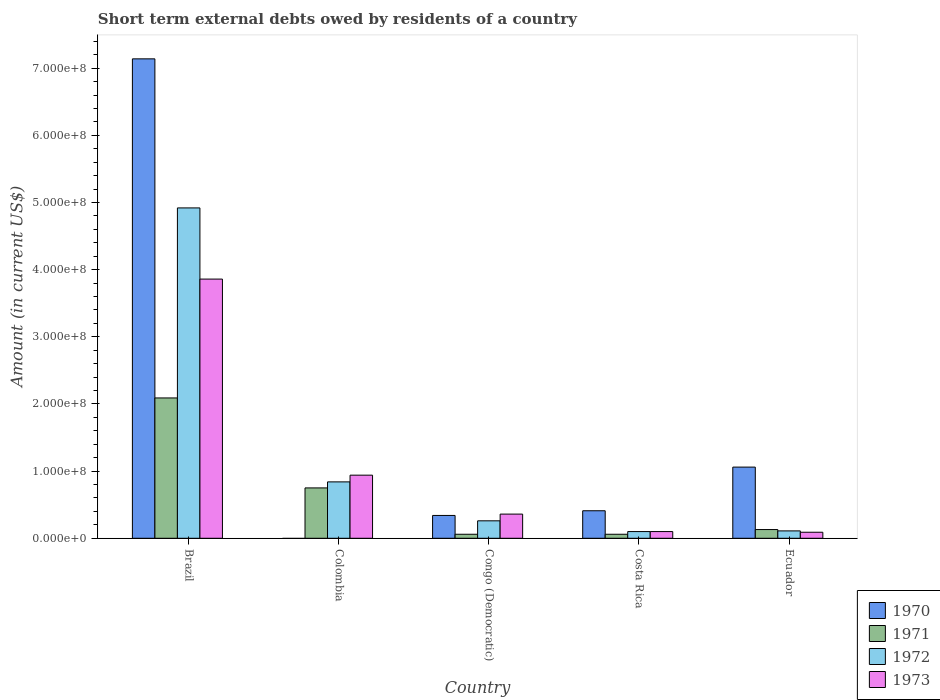How many groups of bars are there?
Offer a terse response. 5. Are the number of bars per tick equal to the number of legend labels?
Your answer should be compact. No. What is the label of the 5th group of bars from the left?
Provide a short and direct response. Ecuador. What is the amount of short-term external debts owed by residents in 1971 in Ecuador?
Make the answer very short. 1.30e+07. Across all countries, what is the maximum amount of short-term external debts owed by residents in 1972?
Ensure brevity in your answer.  4.92e+08. Across all countries, what is the minimum amount of short-term external debts owed by residents in 1972?
Ensure brevity in your answer.  1.00e+07. In which country was the amount of short-term external debts owed by residents in 1970 maximum?
Ensure brevity in your answer.  Brazil. What is the total amount of short-term external debts owed by residents in 1971 in the graph?
Your answer should be compact. 3.09e+08. What is the difference between the amount of short-term external debts owed by residents in 1973 in Colombia and that in Congo (Democratic)?
Keep it short and to the point. 5.80e+07. What is the difference between the amount of short-term external debts owed by residents in 1972 in Colombia and the amount of short-term external debts owed by residents in 1973 in Brazil?
Keep it short and to the point. -3.02e+08. What is the average amount of short-term external debts owed by residents in 1970 per country?
Ensure brevity in your answer.  1.79e+08. What is the difference between the amount of short-term external debts owed by residents of/in 1971 and amount of short-term external debts owed by residents of/in 1973 in Colombia?
Your response must be concise. -1.90e+07. In how many countries, is the amount of short-term external debts owed by residents in 1973 greater than 380000000 US$?
Your answer should be compact. 1. What is the ratio of the amount of short-term external debts owed by residents in 1972 in Colombia to that in Congo (Democratic)?
Your answer should be very brief. 3.23. Is the amount of short-term external debts owed by residents in 1971 in Brazil less than that in Costa Rica?
Give a very brief answer. No. What is the difference between the highest and the second highest amount of short-term external debts owed by residents in 1970?
Keep it short and to the point. 6.73e+08. What is the difference between the highest and the lowest amount of short-term external debts owed by residents in 1970?
Offer a terse response. 7.14e+08. Is it the case that in every country, the sum of the amount of short-term external debts owed by residents in 1970 and amount of short-term external debts owed by residents in 1973 is greater than the amount of short-term external debts owed by residents in 1972?
Offer a very short reply. Yes. Are all the bars in the graph horizontal?
Your answer should be very brief. No. How many countries are there in the graph?
Offer a very short reply. 5. Are the values on the major ticks of Y-axis written in scientific E-notation?
Provide a short and direct response. Yes. Does the graph contain any zero values?
Give a very brief answer. Yes. Where does the legend appear in the graph?
Provide a succinct answer. Bottom right. What is the title of the graph?
Offer a very short reply. Short term external debts owed by residents of a country. Does "1983" appear as one of the legend labels in the graph?
Keep it short and to the point. No. What is the label or title of the Y-axis?
Your answer should be compact. Amount (in current US$). What is the Amount (in current US$) in 1970 in Brazil?
Your answer should be compact. 7.14e+08. What is the Amount (in current US$) of 1971 in Brazil?
Your answer should be very brief. 2.09e+08. What is the Amount (in current US$) in 1972 in Brazil?
Offer a terse response. 4.92e+08. What is the Amount (in current US$) of 1973 in Brazil?
Offer a terse response. 3.86e+08. What is the Amount (in current US$) in 1971 in Colombia?
Offer a terse response. 7.50e+07. What is the Amount (in current US$) of 1972 in Colombia?
Provide a succinct answer. 8.40e+07. What is the Amount (in current US$) of 1973 in Colombia?
Your answer should be compact. 9.40e+07. What is the Amount (in current US$) of 1970 in Congo (Democratic)?
Your answer should be very brief. 3.40e+07. What is the Amount (in current US$) in 1972 in Congo (Democratic)?
Offer a terse response. 2.60e+07. What is the Amount (in current US$) of 1973 in Congo (Democratic)?
Provide a short and direct response. 3.60e+07. What is the Amount (in current US$) of 1970 in Costa Rica?
Provide a short and direct response. 4.10e+07. What is the Amount (in current US$) of 1971 in Costa Rica?
Make the answer very short. 6.00e+06. What is the Amount (in current US$) in 1972 in Costa Rica?
Offer a terse response. 1.00e+07. What is the Amount (in current US$) of 1970 in Ecuador?
Ensure brevity in your answer.  1.06e+08. What is the Amount (in current US$) in 1971 in Ecuador?
Your answer should be very brief. 1.30e+07. What is the Amount (in current US$) in 1972 in Ecuador?
Your answer should be compact. 1.10e+07. What is the Amount (in current US$) of 1973 in Ecuador?
Offer a very short reply. 9.00e+06. Across all countries, what is the maximum Amount (in current US$) in 1970?
Offer a terse response. 7.14e+08. Across all countries, what is the maximum Amount (in current US$) in 1971?
Make the answer very short. 2.09e+08. Across all countries, what is the maximum Amount (in current US$) of 1972?
Keep it short and to the point. 4.92e+08. Across all countries, what is the maximum Amount (in current US$) in 1973?
Your response must be concise. 3.86e+08. Across all countries, what is the minimum Amount (in current US$) of 1973?
Keep it short and to the point. 9.00e+06. What is the total Amount (in current US$) in 1970 in the graph?
Offer a very short reply. 8.95e+08. What is the total Amount (in current US$) in 1971 in the graph?
Give a very brief answer. 3.09e+08. What is the total Amount (in current US$) in 1972 in the graph?
Give a very brief answer. 6.23e+08. What is the total Amount (in current US$) in 1973 in the graph?
Offer a very short reply. 5.35e+08. What is the difference between the Amount (in current US$) of 1971 in Brazil and that in Colombia?
Offer a terse response. 1.34e+08. What is the difference between the Amount (in current US$) of 1972 in Brazil and that in Colombia?
Your answer should be compact. 4.08e+08. What is the difference between the Amount (in current US$) in 1973 in Brazil and that in Colombia?
Ensure brevity in your answer.  2.92e+08. What is the difference between the Amount (in current US$) in 1970 in Brazil and that in Congo (Democratic)?
Make the answer very short. 6.80e+08. What is the difference between the Amount (in current US$) in 1971 in Brazil and that in Congo (Democratic)?
Provide a succinct answer. 2.03e+08. What is the difference between the Amount (in current US$) in 1972 in Brazil and that in Congo (Democratic)?
Keep it short and to the point. 4.66e+08. What is the difference between the Amount (in current US$) in 1973 in Brazil and that in Congo (Democratic)?
Keep it short and to the point. 3.50e+08. What is the difference between the Amount (in current US$) in 1970 in Brazil and that in Costa Rica?
Your answer should be very brief. 6.73e+08. What is the difference between the Amount (in current US$) of 1971 in Brazil and that in Costa Rica?
Ensure brevity in your answer.  2.03e+08. What is the difference between the Amount (in current US$) in 1972 in Brazil and that in Costa Rica?
Ensure brevity in your answer.  4.82e+08. What is the difference between the Amount (in current US$) of 1973 in Brazil and that in Costa Rica?
Provide a succinct answer. 3.76e+08. What is the difference between the Amount (in current US$) of 1970 in Brazil and that in Ecuador?
Make the answer very short. 6.08e+08. What is the difference between the Amount (in current US$) in 1971 in Brazil and that in Ecuador?
Give a very brief answer. 1.96e+08. What is the difference between the Amount (in current US$) in 1972 in Brazil and that in Ecuador?
Give a very brief answer. 4.81e+08. What is the difference between the Amount (in current US$) of 1973 in Brazil and that in Ecuador?
Your answer should be compact. 3.77e+08. What is the difference between the Amount (in current US$) in 1971 in Colombia and that in Congo (Democratic)?
Keep it short and to the point. 6.90e+07. What is the difference between the Amount (in current US$) in 1972 in Colombia and that in Congo (Democratic)?
Your answer should be very brief. 5.80e+07. What is the difference between the Amount (in current US$) in 1973 in Colombia and that in Congo (Democratic)?
Offer a very short reply. 5.80e+07. What is the difference between the Amount (in current US$) of 1971 in Colombia and that in Costa Rica?
Make the answer very short. 6.90e+07. What is the difference between the Amount (in current US$) in 1972 in Colombia and that in Costa Rica?
Your answer should be very brief. 7.40e+07. What is the difference between the Amount (in current US$) in 1973 in Colombia and that in Costa Rica?
Provide a short and direct response. 8.40e+07. What is the difference between the Amount (in current US$) of 1971 in Colombia and that in Ecuador?
Offer a very short reply. 6.20e+07. What is the difference between the Amount (in current US$) of 1972 in Colombia and that in Ecuador?
Provide a succinct answer. 7.30e+07. What is the difference between the Amount (in current US$) in 1973 in Colombia and that in Ecuador?
Give a very brief answer. 8.50e+07. What is the difference between the Amount (in current US$) of 1970 in Congo (Democratic) and that in Costa Rica?
Offer a very short reply. -7.00e+06. What is the difference between the Amount (in current US$) in 1972 in Congo (Democratic) and that in Costa Rica?
Give a very brief answer. 1.60e+07. What is the difference between the Amount (in current US$) of 1973 in Congo (Democratic) and that in Costa Rica?
Provide a short and direct response. 2.60e+07. What is the difference between the Amount (in current US$) in 1970 in Congo (Democratic) and that in Ecuador?
Your response must be concise. -7.20e+07. What is the difference between the Amount (in current US$) of 1971 in Congo (Democratic) and that in Ecuador?
Offer a very short reply. -7.00e+06. What is the difference between the Amount (in current US$) in 1972 in Congo (Democratic) and that in Ecuador?
Offer a terse response. 1.50e+07. What is the difference between the Amount (in current US$) of 1973 in Congo (Democratic) and that in Ecuador?
Offer a terse response. 2.70e+07. What is the difference between the Amount (in current US$) in 1970 in Costa Rica and that in Ecuador?
Ensure brevity in your answer.  -6.50e+07. What is the difference between the Amount (in current US$) in 1971 in Costa Rica and that in Ecuador?
Make the answer very short. -7.00e+06. What is the difference between the Amount (in current US$) of 1973 in Costa Rica and that in Ecuador?
Ensure brevity in your answer.  1.00e+06. What is the difference between the Amount (in current US$) of 1970 in Brazil and the Amount (in current US$) of 1971 in Colombia?
Offer a very short reply. 6.39e+08. What is the difference between the Amount (in current US$) of 1970 in Brazil and the Amount (in current US$) of 1972 in Colombia?
Your response must be concise. 6.30e+08. What is the difference between the Amount (in current US$) of 1970 in Brazil and the Amount (in current US$) of 1973 in Colombia?
Your answer should be compact. 6.20e+08. What is the difference between the Amount (in current US$) in 1971 in Brazil and the Amount (in current US$) in 1972 in Colombia?
Ensure brevity in your answer.  1.25e+08. What is the difference between the Amount (in current US$) of 1971 in Brazil and the Amount (in current US$) of 1973 in Colombia?
Give a very brief answer. 1.15e+08. What is the difference between the Amount (in current US$) of 1972 in Brazil and the Amount (in current US$) of 1973 in Colombia?
Offer a very short reply. 3.98e+08. What is the difference between the Amount (in current US$) of 1970 in Brazil and the Amount (in current US$) of 1971 in Congo (Democratic)?
Ensure brevity in your answer.  7.08e+08. What is the difference between the Amount (in current US$) in 1970 in Brazil and the Amount (in current US$) in 1972 in Congo (Democratic)?
Offer a very short reply. 6.88e+08. What is the difference between the Amount (in current US$) of 1970 in Brazil and the Amount (in current US$) of 1973 in Congo (Democratic)?
Offer a terse response. 6.78e+08. What is the difference between the Amount (in current US$) of 1971 in Brazil and the Amount (in current US$) of 1972 in Congo (Democratic)?
Your answer should be compact. 1.83e+08. What is the difference between the Amount (in current US$) in 1971 in Brazil and the Amount (in current US$) in 1973 in Congo (Democratic)?
Offer a very short reply. 1.73e+08. What is the difference between the Amount (in current US$) in 1972 in Brazil and the Amount (in current US$) in 1973 in Congo (Democratic)?
Offer a very short reply. 4.56e+08. What is the difference between the Amount (in current US$) in 1970 in Brazil and the Amount (in current US$) in 1971 in Costa Rica?
Your answer should be compact. 7.08e+08. What is the difference between the Amount (in current US$) of 1970 in Brazil and the Amount (in current US$) of 1972 in Costa Rica?
Give a very brief answer. 7.04e+08. What is the difference between the Amount (in current US$) in 1970 in Brazil and the Amount (in current US$) in 1973 in Costa Rica?
Ensure brevity in your answer.  7.04e+08. What is the difference between the Amount (in current US$) in 1971 in Brazil and the Amount (in current US$) in 1972 in Costa Rica?
Your answer should be compact. 1.99e+08. What is the difference between the Amount (in current US$) in 1971 in Brazil and the Amount (in current US$) in 1973 in Costa Rica?
Provide a succinct answer. 1.99e+08. What is the difference between the Amount (in current US$) in 1972 in Brazil and the Amount (in current US$) in 1973 in Costa Rica?
Offer a very short reply. 4.82e+08. What is the difference between the Amount (in current US$) of 1970 in Brazil and the Amount (in current US$) of 1971 in Ecuador?
Offer a terse response. 7.01e+08. What is the difference between the Amount (in current US$) of 1970 in Brazil and the Amount (in current US$) of 1972 in Ecuador?
Ensure brevity in your answer.  7.03e+08. What is the difference between the Amount (in current US$) of 1970 in Brazil and the Amount (in current US$) of 1973 in Ecuador?
Your answer should be compact. 7.05e+08. What is the difference between the Amount (in current US$) in 1971 in Brazil and the Amount (in current US$) in 1972 in Ecuador?
Make the answer very short. 1.98e+08. What is the difference between the Amount (in current US$) of 1972 in Brazil and the Amount (in current US$) of 1973 in Ecuador?
Offer a very short reply. 4.83e+08. What is the difference between the Amount (in current US$) in 1971 in Colombia and the Amount (in current US$) in 1972 in Congo (Democratic)?
Make the answer very short. 4.90e+07. What is the difference between the Amount (in current US$) of 1971 in Colombia and the Amount (in current US$) of 1973 in Congo (Democratic)?
Provide a succinct answer. 3.90e+07. What is the difference between the Amount (in current US$) in 1972 in Colombia and the Amount (in current US$) in 1973 in Congo (Democratic)?
Ensure brevity in your answer.  4.80e+07. What is the difference between the Amount (in current US$) of 1971 in Colombia and the Amount (in current US$) of 1972 in Costa Rica?
Make the answer very short. 6.50e+07. What is the difference between the Amount (in current US$) of 1971 in Colombia and the Amount (in current US$) of 1973 in Costa Rica?
Give a very brief answer. 6.50e+07. What is the difference between the Amount (in current US$) of 1972 in Colombia and the Amount (in current US$) of 1973 in Costa Rica?
Your answer should be very brief. 7.40e+07. What is the difference between the Amount (in current US$) in 1971 in Colombia and the Amount (in current US$) in 1972 in Ecuador?
Provide a short and direct response. 6.40e+07. What is the difference between the Amount (in current US$) in 1971 in Colombia and the Amount (in current US$) in 1973 in Ecuador?
Your answer should be very brief. 6.60e+07. What is the difference between the Amount (in current US$) of 1972 in Colombia and the Amount (in current US$) of 1973 in Ecuador?
Offer a very short reply. 7.50e+07. What is the difference between the Amount (in current US$) in 1970 in Congo (Democratic) and the Amount (in current US$) in 1971 in Costa Rica?
Give a very brief answer. 2.80e+07. What is the difference between the Amount (in current US$) of 1970 in Congo (Democratic) and the Amount (in current US$) of 1972 in Costa Rica?
Make the answer very short. 2.40e+07. What is the difference between the Amount (in current US$) of 1970 in Congo (Democratic) and the Amount (in current US$) of 1973 in Costa Rica?
Provide a succinct answer. 2.40e+07. What is the difference between the Amount (in current US$) of 1971 in Congo (Democratic) and the Amount (in current US$) of 1973 in Costa Rica?
Give a very brief answer. -4.00e+06. What is the difference between the Amount (in current US$) of 1972 in Congo (Democratic) and the Amount (in current US$) of 1973 in Costa Rica?
Ensure brevity in your answer.  1.60e+07. What is the difference between the Amount (in current US$) in 1970 in Congo (Democratic) and the Amount (in current US$) in 1971 in Ecuador?
Provide a succinct answer. 2.10e+07. What is the difference between the Amount (in current US$) of 1970 in Congo (Democratic) and the Amount (in current US$) of 1972 in Ecuador?
Your answer should be compact. 2.30e+07. What is the difference between the Amount (in current US$) of 1970 in Congo (Democratic) and the Amount (in current US$) of 1973 in Ecuador?
Give a very brief answer. 2.50e+07. What is the difference between the Amount (in current US$) of 1971 in Congo (Democratic) and the Amount (in current US$) of 1972 in Ecuador?
Keep it short and to the point. -5.00e+06. What is the difference between the Amount (in current US$) in 1972 in Congo (Democratic) and the Amount (in current US$) in 1973 in Ecuador?
Provide a succinct answer. 1.70e+07. What is the difference between the Amount (in current US$) in 1970 in Costa Rica and the Amount (in current US$) in 1971 in Ecuador?
Make the answer very short. 2.80e+07. What is the difference between the Amount (in current US$) of 1970 in Costa Rica and the Amount (in current US$) of 1972 in Ecuador?
Your answer should be very brief. 3.00e+07. What is the difference between the Amount (in current US$) of 1970 in Costa Rica and the Amount (in current US$) of 1973 in Ecuador?
Keep it short and to the point. 3.20e+07. What is the difference between the Amount (in current US$) in 1971 in Costa Rica and the Amount (in current US$) in 1972 in Ecuador?
Ensure brevity in your answer.  -5.00e+06. What is the difference between the Amount (in current US$) of 1971 in Costa Rica and the Amount (in current US$) of 1973 in Ecuador?
Offer a terse response. -3.00e+06. What is the average Amount (in current US$) in 1970 per country?
Provide a short and direct response. 1.79e+08. What is the average Amount (in current US$) of 1971 per country?
Provide a short and direct response. 6.18e+07. What is the average Amount (in current US$) of 1972 per country?
Offer a terse response. 1.25e+08. What is the average Amount (in current US$) in 1973 per country?
Keep it short and to the point. 1.07e+08. What is the difference between the Amount (in current US$) of 1970 and Amount (in current US$) of 1971 in Brazil?
Your answer should be compact. 5.05e+08. What is the difference between the Amount (in current US$) in 1970 and Amount (in current US$) in 1972 in Brazil?
Offer a very short reply. 2.22e+08. What is the difference between the Amount (in current US$) of 1970 and Amount (in current US$) of 1973 in Brazil?
Offer a very short reply. 3.28e+08. What is the difference between the Amount (in current US$) in 1971 and Amount (in current US$) in 1972 in Brazil?
Provide a short and direct response. -2.83e+08. What is the difference between the Amount (in current US$) of 1971 and Amount (in current US$) of 1973 in Brazil?
Your answer should be very brief. -1.77e+08. What is the difference between the Amount (in current US$) in 1972 and Amount (in current US$) in 1973 in Brazil?
Keep it short and to the point. 1.06e+08. What is the difference between the Amount (in current US$) of 1971 and Amount (in current US$) of 1972 in Colombia?
Offer a very short reply. -9.00e+06. What is the difference between the Amount (in current US$) of 1971 and Amount (in current US$) of 1973 in Colombia?
Ensure brevity in your answer.  -1.90e+07. What is the difference between the Amount (in current US$) of 1972 and Amount (in current US$) of 1973 in Colombia?
Provide a short and direct response. -1.00e+07. What is the difference between the Amount (in current US$) in 1970 and Amount (in current US$) in 1971 in Congo (Democratic)?
Keep it short and to the point. 2.80e+07. What is the difference between the Amount (in current US$) in 1970 and Amount (in current US$) in 1973 in Congo (Democratic)?
Provide a short and direct response. -2.00e+06. What is the difference between the Amount (in current US$) of 1971 and Amount (in current US$) of 1972 in Congo (Democratic)?
Keep it short and to the point. -2.00e+07. What is the difference between the Amount (in current US$) in 1971 and Amount (in current US$) in 1973 in Congo (Democratic)?
Make the answer very short. -3.00e+07. What is the difference between the Amount (in current US$) of 1972 and Amount (in current US$) of 1973 in Congo (Democratic)?
Give a very brief answer. -1.00e+07. What is the difference between the Amount (in current US$) in 1970 and Amount (in current US$) in 1971 in Costa Rica?
Your answer should be very brief. 3.50e+07. What is the difference between the Amount (in current US$) of 1970 and Amount (in current US$) of 1972 in Costa Rica?
Give a very brief answer. 3.10e+07. What is the difference between the Amount (in current US$) in 1970 and Amount (in current US$) in 1973 in Costa Rica?
Your answer should be very brief. 3.10e+07. What is the difference between the Amount (in current US$) in 1971 and Amount (in current US$) in 1973 in Costa Rica?
Your answer should be very brief. -4.00e+06. What is the difference between the Amount (in current US$) in 1970 and Amount (in current US$) in 1971 in Ecuador?
Your response must be concise. 9.30e+07. What is the difference between the Amount (in current US$) of 1970 and Amount (in current US$) of 1972 in Ecuador?
Provide a short and direct response. 9.50e+07. What is the difference between the Amount (in current US$) of 1970 and Amount (in current US$) of 1973 in Ecuador?
Offer a terse response. 9.70e+07. What is the difference between the Amount (in current US$) of 1971 and Amount (in current US$) of 1972 in Ecuador?
Your answer should be compact. 2.00e+06. What is the difference between the Amount (in current US$) in 1971 and Amount (in current US$) in 1973 in Ecuador?
Your answer should be very brief. 4.00e+06. What is the ratio of the Amount (in current US$) in 1971 in Brazil to that in Colombia?
Your response must be concise. 2.79. What is the ratio of the Amount (in current US$) in 1972 in Brazil to that in Colombia?
Make the answer very short. 5.86. What is the ratio of the Amount (in current US$) of 1973 in Brazil to that in Colombia?
Offer a terse response. 4.11. What is the ratio of the Amount (in current US$) of 1970 in Brazil to that in Congo (Democratic)?
Ensure brevity in your answer.  21. What is the ratio of the Amount (in current US$) in 1971 in Brazil to that in Congo (Democratic)?
Offer a terse response. 34.83. What is the ratio of the Amount (in current US$) in 1972 in Brazil to that in Congo (Democratic)?
Keep it short and to the point. 18.92. What is the ratio of the Amount (in current US$) of 1973 in Brazil to that in Congo (Democratic)?
Give a very brief answer. 10.72. What is the ratio of the Amount (in current US$) in 1970 in Brazil to that in Costa Rica?
Provide a succinct answer. 17.41. What is the ratio of the Amount (in current US$) in 1971 in Brazil to that in Costa Rica?
Provide a short and direct response. 34.83. What is the ratio of the Amount (in current US$) in 1972 in Brazil to that in Costa Rica?
Provide a succinct answer. 49.2. What is the ratio of the Amount (in current US$) of 1973 in Brazil to that in Costa Rica?
Offer a very short reply. 38.6. What is the ratio of the Amount (in current US$) in 1970 in Brazil to that in Ecuador?
Your answer should be very brief. 6.74. What is the ratio of the Amount (in current US$) of 1971 in Brazil to that in Ecuador?
Keep it short and to the point. 16.08. What is the ratio of the Amount (in current US$) of 1972 in Brazil to that in Ecuador?
Keep it short and to the point. 44.73. What is the ratio of the Amount (in current US$) in 1973 in Brazil to that in Ecuador?
Make the answer very short. 42.89. What is the ratio of the Amount (in current US$) of 1972 in Colombia to that in Congo (Democratic)?
Provide a short and direct response. 3.23. What is the ratio of the Amount (in current US$) in 1973 in Colombia to that in Congo (Democratic)?
Give a very brief answer. 2.61. What is the ratio of the Amount (in current US$) of 1971 in Colombia to that in Ecuador?
Ensure brevity in your answer.  5.77. What is the ratio of the Amount (in current US$) of 1972 in Colombia to that in Ecuador?
Provide a succinct answer. 7.64. What is the ratio of the Amount (in current US$) of 1973 in Colombia to that in Ecuador?
Provide a succinct answer. 10.44. What is the ratio of the Amount (in current US$) in 1970 in Congo (Democratic) to that in Costa Rica?
Ensure brevity in your answer.  0.83. What is the ratio of the Amount (in current US$) of 1972 in Congo (Democratic) to that in Costa Rica?
Provide a succinct answer. 2.6. What is the ratio of the Amount (in current US$) in 1970 in Congo (Democratic) to that in Ecuador?
Offer a very short reply. 0.32. What is the ratio of the Amount (in current US$) of 1971 in Congo (Democratic) to that in Ecuador?
Your answer should be very brief. 0.46. What is the ratio of the Amount (in current US$) in 1972 in Congo (Democratic) to that in Ecuador?
Offer a very short reply. 2.36. What is the ratio of the Amount (in current US$) in 1973 in Congo (Democratic) to that in Ecuador?
Provide a succinct answer. 4. What is the ratio of the Amount (in current US$) of 1970 in Costa Rica to that in Ecuador?
Your answer should be compact. 0.39. What is the ratio of the Amount (in current US$) in 1971 in Costa Rica to that in Ecuador?
Provide a succinct answer. 0.46. What is the ratio of the Amount (in current US$) in 1972 in Costa Rica to that in Ecuador?
Provide a short and direct response. 0.91. What is the ratio of the Amount (in current US$) in 1973 in Costa Rica to that in Ecuador?
Give a very brief answer. 1.11. What is the difference between the highest and the second highest Amount (in current US$) in 1970?
Your answer should be compact. 6.08e+08. What is the difference between the highest and the second highest Amount (in current US$) of 1971?
Give a very brief answer. 1.34e+08. What is the difference between the highest and the second highest Amount (in current US$) in 1972?
Provide a succinct answer. 4.08e+08. What is the difference between the highest and the second highest Amount (in current US$) in 1973?
Your response must be concise. 2.92e+08. What is the difference between the highest and the lowest Amount (in current US$) in 1970?
Make the answer very short. 7.14e+08. What is the difference between the highest and the lowest Amount (in current US$) in 1971?
Your answer should be compact. 2.03e+08. What is the difference between the highest and the lowest Amount (in current US$) in 1972?
Your answer should be very brief. 4.82e+08. What is the difference between the highest and the lowest Amount (in current US$) of 1973?
Your response must be concise. 3.77e+08. 